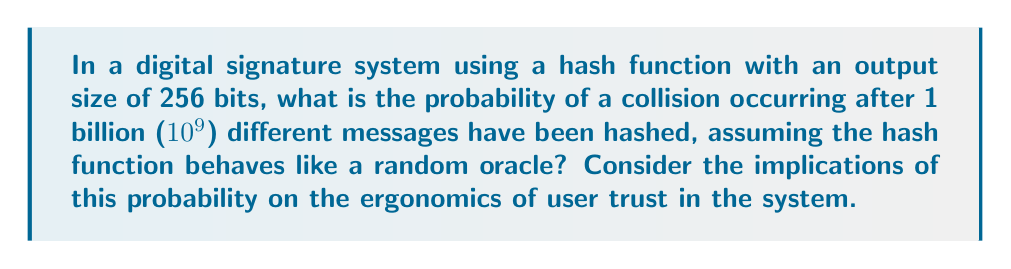Could you help me with this problem? To solve this problem, we'll use the birthday paradox approximation, which is applicable to hash collision probabilities:

1. First, we need to determine the number of possible hash outputs:
   $n = 2^{256}$ (since the hash function has a 256-bit output)

2. The number of hashed messages is $m = 10^9$

3. The birthday paradox approximation for collision probability is:
   $P(\text{collision}) \approx 1 - e^{-\frac{m^2}{2n}}$

4. Substituting our values:
   $P(\text{collision}) \approx 1 - e^{-\frac{(10^9)^2}{2 \cdot 2^{256}}}$

5. Simplify the exponent:
   $\frac{(10^9)^2}{2 \cdot 2^{256}} = \frac{10^{18}}{2 \cdot 2^{256}} \approx 2.7 \times 10^{-60}$

6. Calculate the final probability:
   $P(\text{collision}) \approx 1 - e^{-2.7 \times 10^{-60}} \approx 2.7 \times 10^{-60}$

From an ergonomics perspective, this extremely low probability (approximately 1 in $3.7 \times 10^{59}$) suggests that users can have high confidence in the system's integrity, as collisions are virtually impossible in practical scenarios. This contributes to a positive user experience and trust in the digital signature system.
Answer: $2.7 \times 10^{-60}$ 